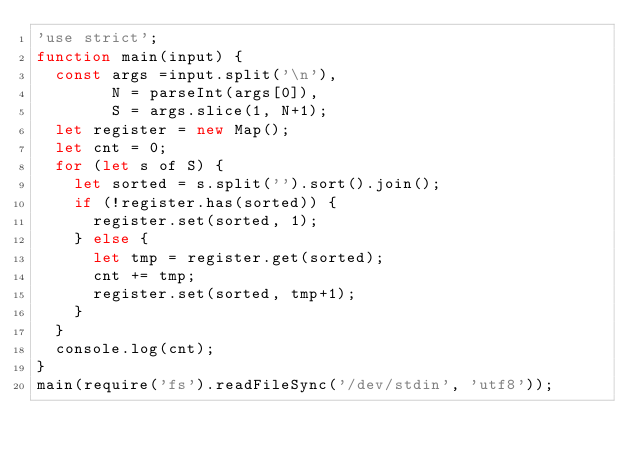<code> <loc_0><loc_0><loc_500><loc_500><_JavaScript_>'use strict';
function main(input) {
  const args =input.split('\n'),
        N = parseInt(args[0]),
        S = args.slice(1, N+1);
  let register = new Map();
  let cnt = 0;
  for (let s of S) {
    let sorted = s.split('').sort().join();
    if (!register.has(sorted)) {
      register.set(sorted, 1);
    } else {
      let tmp = register.get(sorted);
      cnt += tmp;
      register.set(sorted, tmp+1);
    }
  }
  console.log(cnt);
}
main(require('fs').readFileSync('/dev/stdin', 'utf8'));</code> 